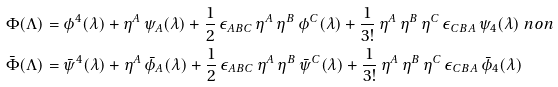<formula> <loc_0><loc_0><loc_500><loc_500>\Phi ( \Lambda ) & = \phi ^ { 4 } ( \lambda ) + \eta ^ { A } \, \psi _ { A } ( \lambda ) + \frac { 1 } { 2 } \, \epsilon _ { A B C } \, \eta ^ { A } \, \eta ^ { B } \, \phi ^ { C } ( \lambda ) + \frac { 1 } { 3 ! } \, \eta ^ { A } \, \eta ^ { B } \, \eta ^ { C } \, \epsilon _ { C B A } \, \psi _ { 4 } ( \lambda ) \ n o n \\ \bar { \Phi } ( \Lambda ) & = \bar { \psi } ^ { 4 } ( \lambda ) + \eta ^ { A } \, \bar { \phi } _ { A } ( \lambda ) + \frac { 1 } { 2 } \, \epsilon _ { A B C } \, \eta ^ { A } \, \eta ^ { B } \, \bar { \psi } ^ { C } ( \lambda ) + \frac { 1 } { 3 ! } \, \eta ^ { A } \, \eta ^ { B } \, \eta ^ { C } \, \epsilon _ { C B A } \, \bar { \phi } _ { 4 } ( \lambda )</formula> 